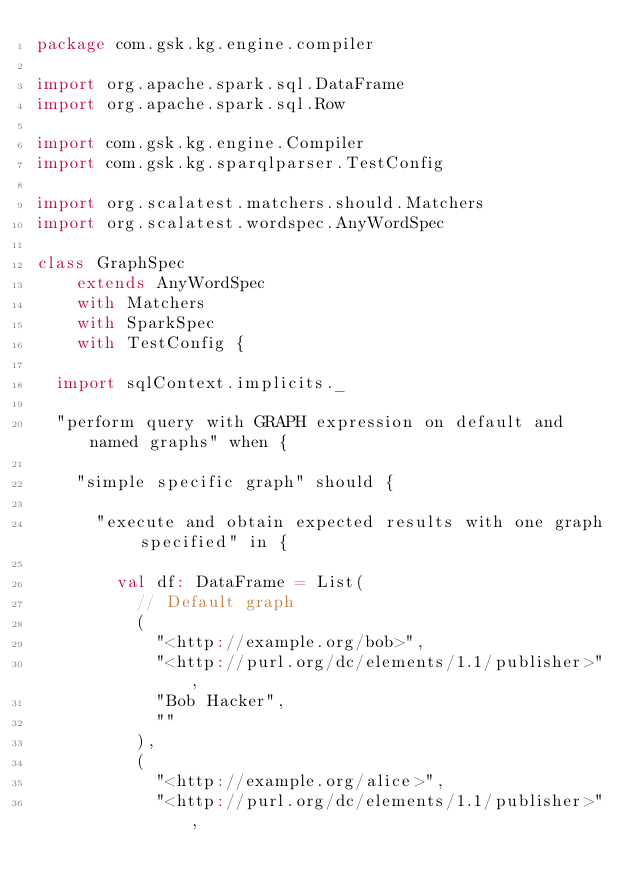<code> <loc_0><loc_0><loc_500><loc_500><_Scala_>package com.gsk.kg.engine.compiler

import org.apache.spark.sql.DataFrame
import org.apache.spark.sql.Row

import com.gsk.kg.engine.Compiler
import com.gsk.kg.sparqlparser.TestConfig

import org.scalatest.matchers.should.Matchers
import org.scalatest.wordspec.AnyWordSpec

class GraphSpec
    extends AnyWordSpec
    with Matchers
    with SparkSpec
    with TestConfig {

  import sqlContext.implicits._

  "perform query with GRAPH expression on default and named graphs" when {

    "simple specific graph" should {

      "execute and obtain expected results with one graph specified" in {

        val df: DataFrame = List(
          // Default graph
          (
            "<http://example.org/bob>",
            "<http://purl.org/dc/elements/1.1/publisher>",
            "Bob Hacker",
            ""
          ),
          (
            "<http://example.org/alice>",
            "<http://purl.org/dc/elements/1.1/publisher>",</code> 